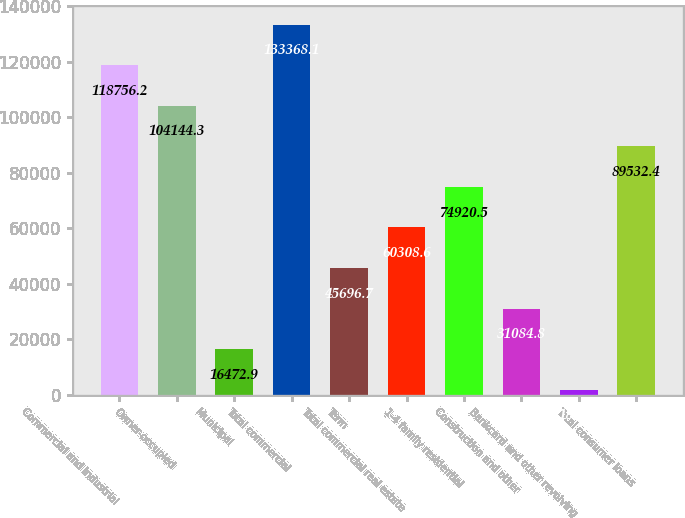Convert chart to OTSL. <chart><loc_0><loc_0><loc_500><loc_500><bar_chart><fcel>Commercial and industrial<fcel>Owner-occupied<fcel>Municipal<fcel>Total commercial<fcel>Term<fcel>Total commercial real estate<fcel>1-4 family residential<fcel>Construction and other<fcel>Bankcard and other revolving<fcel>Total consumer loans<nl><fcel>118756<fcel>104144<fcel>16472.9<fcel>133368<fcel>45696.7<fcel>60308.6<fcel>74920.5<fcel>31084.8<fcel>1861<fcel>89532.4<nl></chart> 